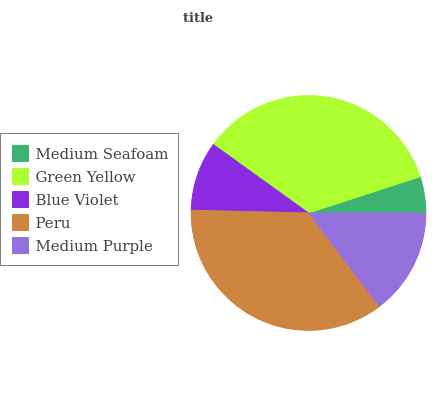Is Medium Seafoam the minimum?
Answer yes or no. Yes. Is Peru the maximum?
Answer yes or no. Yes. Is Green Yellow the minimum?
Answer yes or no. No. Is Green Yellow the maximum?
Answer yes or no. No. Is Green Yellow greater than Medium Seafoam?
Answer yes or no. Yes. Is Medium Seafoam less than Green Yellow?
Answer yes or no. Yes. Is Medium Seafoam greater than Green Yellow?
Answer yes or no. No. Is Green Yellow less than Medium Seafoam?
Answer yes or no. No. Is Medium Purple the high median?
Answer yes or no. Yes. Is Medium Purple the low median?
Answer yes or no. Yes. Is Blue Violet the high median?
Answer yes or no. No. Is Peru the low median?
Answer yes or no. No. 